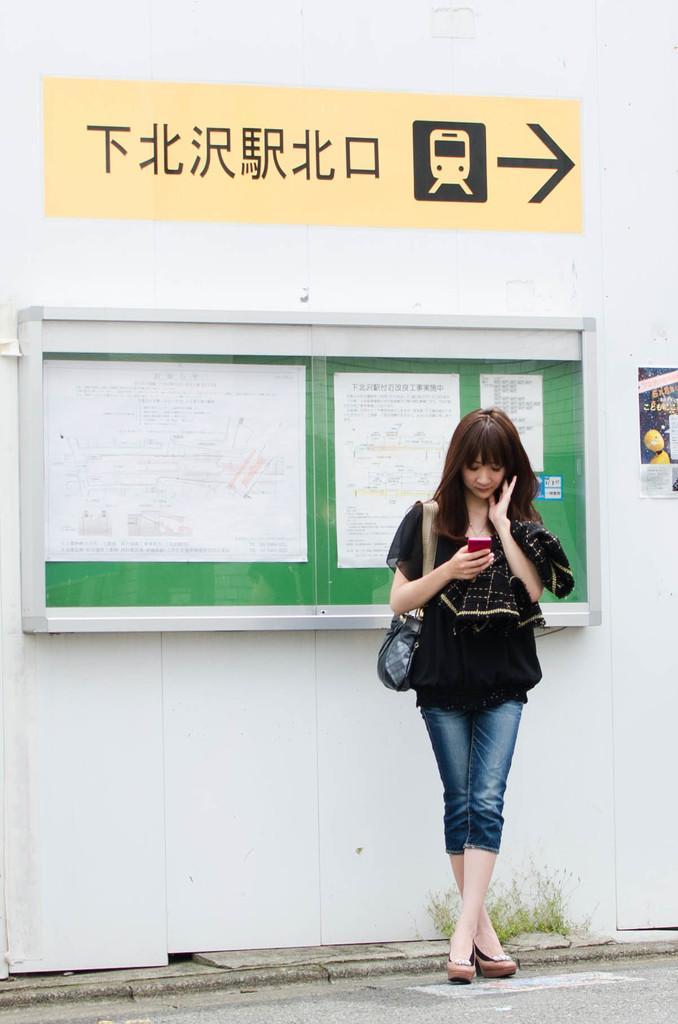Describe this image in one or two sentences. In this picture we can see a woman is standing and holding a mobile phone, she is carrying a bag, in the background there is a board, we can see papers pasted on the board, there is a poster pasted on the wall, we can see some text at the top of the picture, at the bottom there is a plant. 